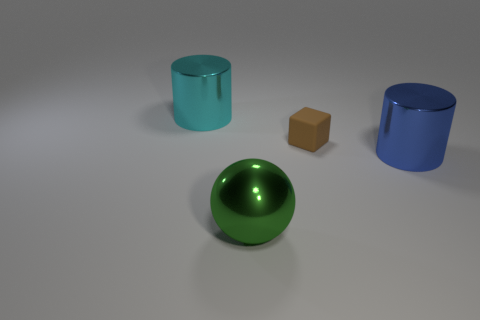Are there any other things that have the same material as the ball? Based on the appearance of the objects in the image, it seems the ball has a shiny, reflective surface similar to that of the two cylinders, suggesting they might be made from a similar material, such as a polished metal or a reflective plastic. 